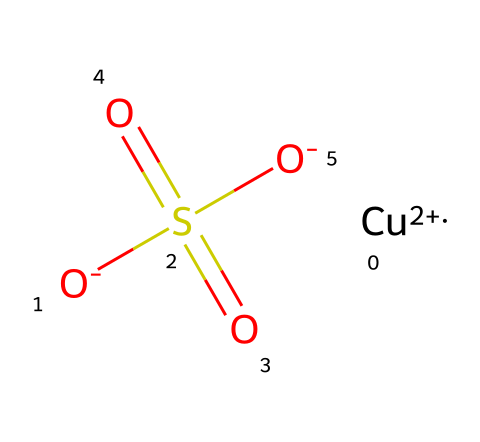What is the total number of oxygen atoms in copper sulfate? In the given SMILES representation, there are two O atoms represented as [O-] (each oxygen has a negative charge) and two other oxygen atoms in the sulfate group (O= and the other two O-). This totals four oxygen atoms.
Answer: four What is the oxidation state of copper in this compound? The copper ion is represented as [Cu+2] in the SMILES notation, which directly indicates that it has a +2 oxidation state.
Answer: +2 How many sulfur atoms are present in the structure? The SMILES representation contains only one sulfur atom designated by the S in the sulfate group structure.
Answer: one What type of bond connects the copper ion to the sulfate moiety? The copper ion is complexed with the sulfate by ionic bonds, as indicated by the presence of the charged [Cu+2] and the negatively charged sulfate ion.
Answer: ionic bond What functional group is present in copper sulfate? The presence of the sulfate group (SO4) in the structure identifies the functional group involved, making it a sulfate compound.
Answer: sulfate Which element, indicated in the structure, typically contributes to the effectiveness of the substance as a fungicide? Copper is the key element in the structure that provides antifungal properties, as it is well known for its role in various fungicides.
Answer: copper How would you classify copper sulfate based on its solubility properties in water? Copper sulfate is a soluble compound, as shown by its usual behavior when added to water, where it dissociates into ions.
Answer: soluble 